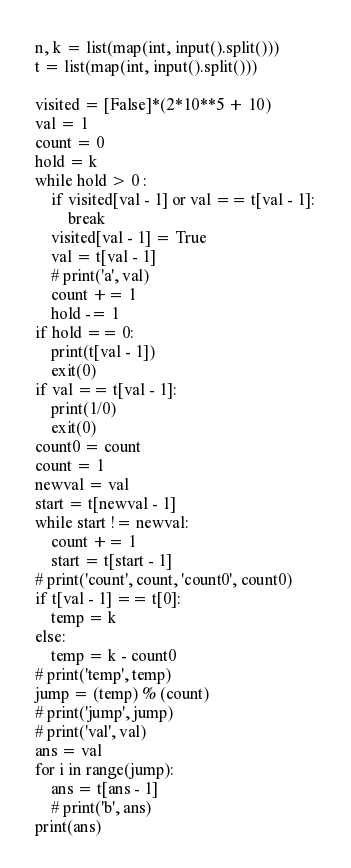Convert code to text. <code><loc_0><loc_0><loc_500><loc_500><_Python_>n, k = list(map(int, input().split()))
t = list(map(int, input().split()))

visited = [False]*(2*10**5 + 10)
val = 1
count = 0
hold = k
while hold > 0 :
    if visited[val - 1] or val == t[val - 1]:
        break
    visited[val - 1] = True
    val = t[val - 1]
    # print('a', val)
    count += 1
    hold -= 1
if hold == 0:
    print(t[val - 1])
    exit(0)
if val == t[val - 1]:
    print(1/0)
    exit(0)
count0 = count
count = 1
newval = val
start = t[newval - 1]
while start != newval:
    count += 1
    start = t[start - 1]
# print('count', count, 'count0', count0)
if t[val - 1] == t[0]:
    temp = k
else:
    temp = k - count0
# print('temp', temp)
jump = (temp) % (count)
# print('jump', jump)
# print('val', val)
ans = val
for i in range(jump):
    ans = t[ans - 1]
    # print('b', ans)
print(ans)</code> 